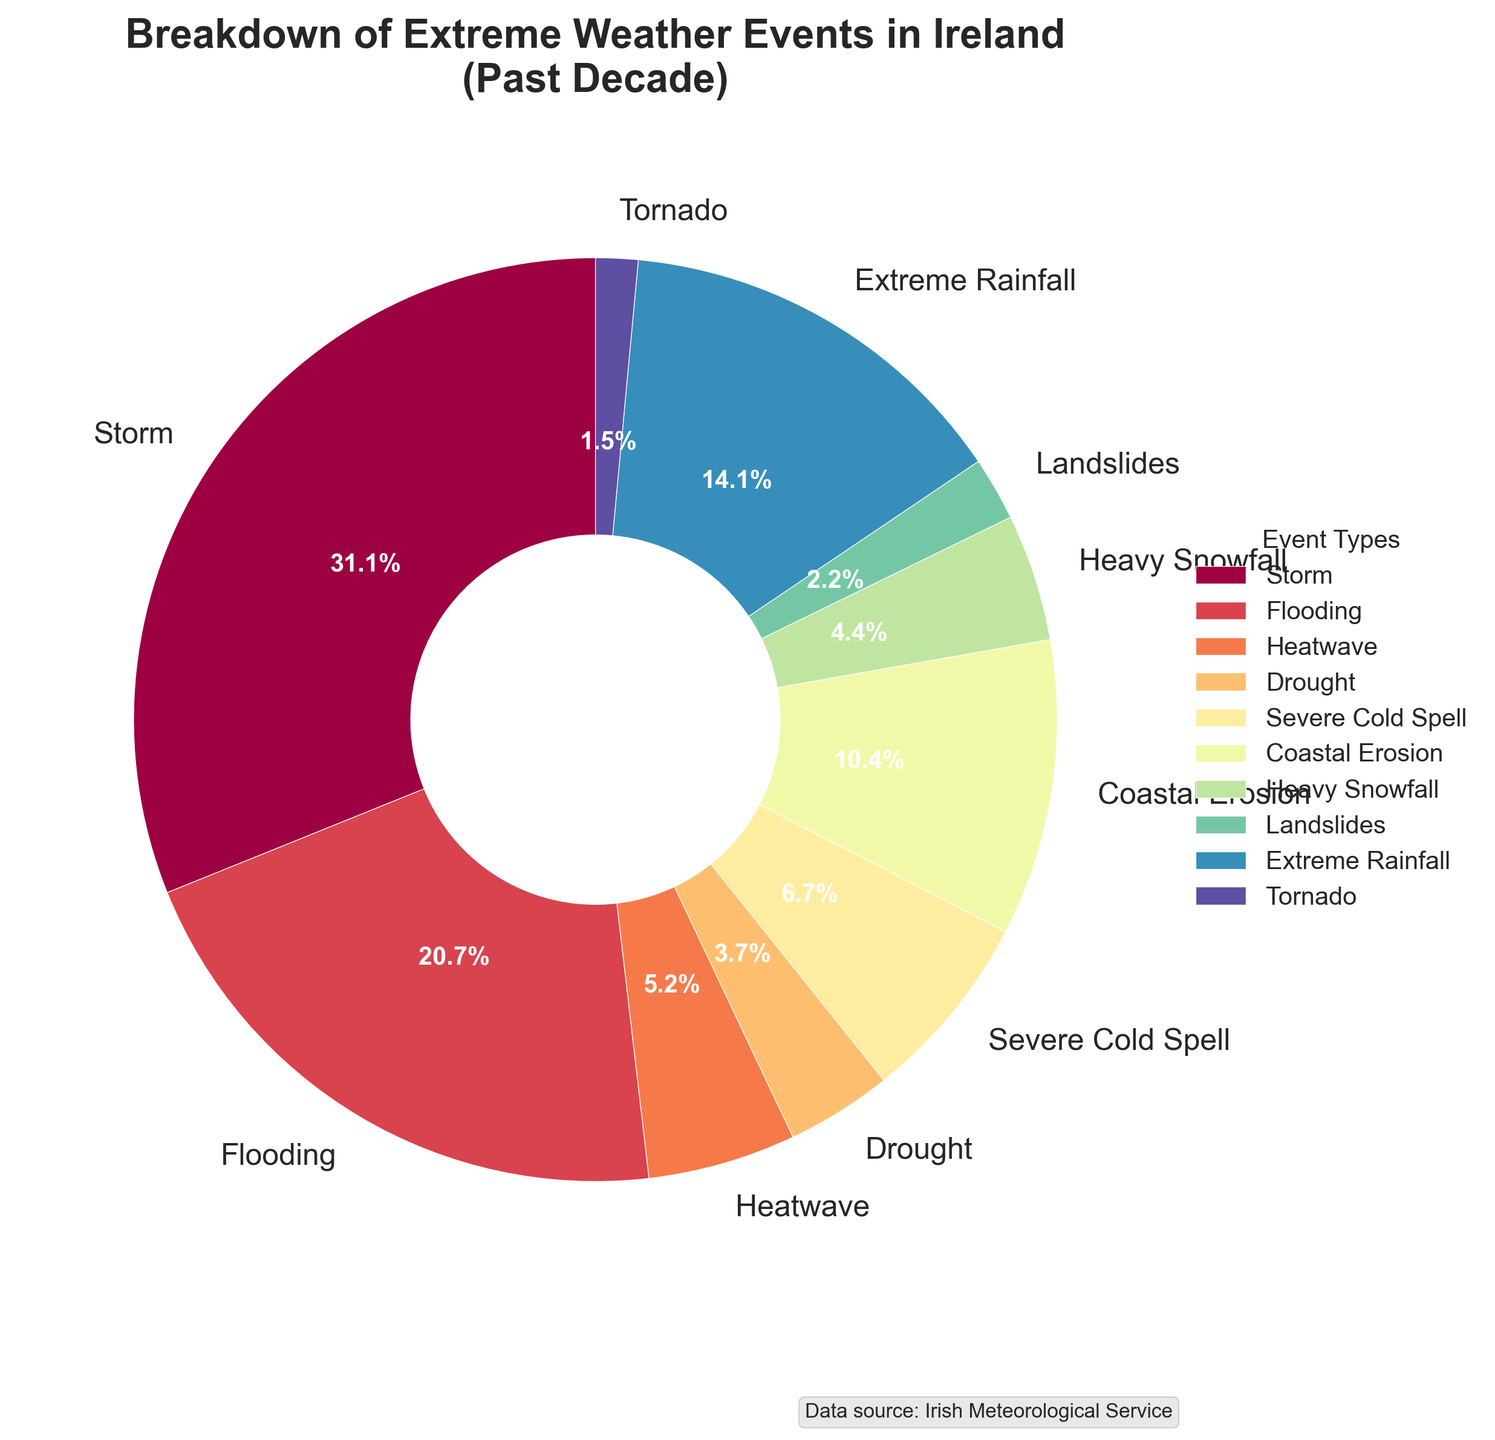Which extreme weather event has the highest occurrence in the past decade in Ireland? The figure shows a pie chart with varying portions representing different weather events. The event "Storm" has the largest slice.
Answer: Storm What percentage of the extreme weather events in Ireland does Heavy Snowfall account for? The pie chart provides the percentage for each event. "Heavy Snowfall" is shown to account for 6%.
Answer: 6% How many more occurrences of Storms are there compared to Tornadoes? The chart indicates the number of each event. Storms occur 42 times while Tornadoes occur 2 times. The difference is 42 - 2.
Answer: 40 Which event type is more frequent: Coastal Erosion or Severe Cold Spell? The pie chart segments reveal that Coastal Erosion has 14 occurrences while Severe Cold Spell has 9 occurrences. Coastal Erosion is more frequent.
Answer: Coastal Erosion What is the combined percentage of Drought and Heatwave events? The chart shows that Drought accounts for 4.9% and Heatwave for 6.9%. Summing these percentages gives 4.9 + 6.9.
Answer: 11.8% Compare the occurrences of Flooding and Extreme Rainfall events. Which is more, and by how much? The pie chart indicates Flooding with 28 occurrences and Extreme Rainfall with 19 occurrences. The difference is 28 - 19.
Answer: Flooding by 9 What is the least common extreme weather event in Ireland over the past decade? The smallest slice in the pie chart represents Tornado, which has the fewest occurrences.
Answer: Tornado Calculate the total number of extreme weather events depicted in the pie chart. From the chart, sum all occurrences: 42 (Storm) + 28 (Flooding) + 7 (Heatwave) + 5 (Drought) + 9 (Severe Cold Spell) + 14 (Coastal Erosion) + 6 (Heavy Snowfall) + 3 (Landslides) + 19 (Extreme Rainfall) + 2 (Tornado). The total is 135.
Answer: 135 Which event type accounts for nearly 13% of the extreme weather events? The pie chart label shows Coastal Erosion making up 13.5% of the events.
Answer: Coastal Erosion 